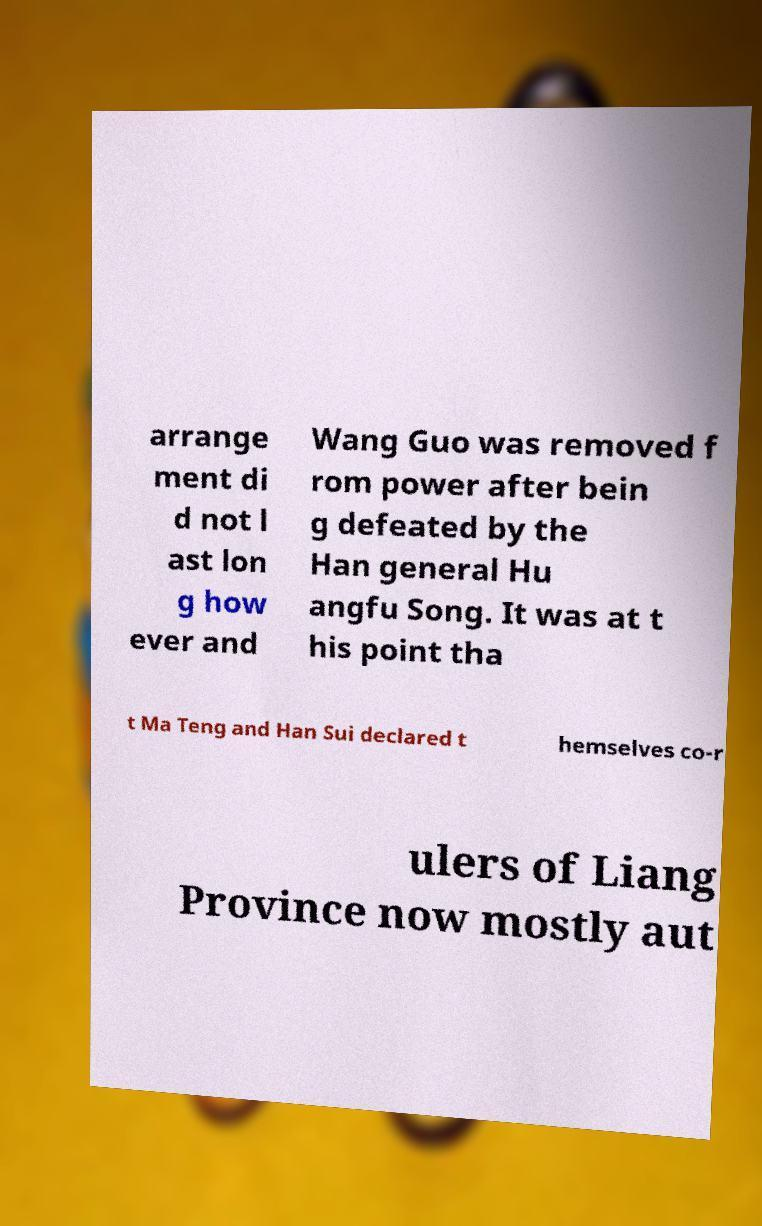Can you read and provide the text displayed in the image?This photo seems to have some interesting text. Can you extract and type it out for me? arrange ment di d not l ast lon g how ever and Wang Guo was removed f rom power after bein g defeated by the Han general Hu angfu Song. It was at t his point tha t Ma Teng and Han Sui declared t hemselves co-r ulers of Liang Province now mostly aut 